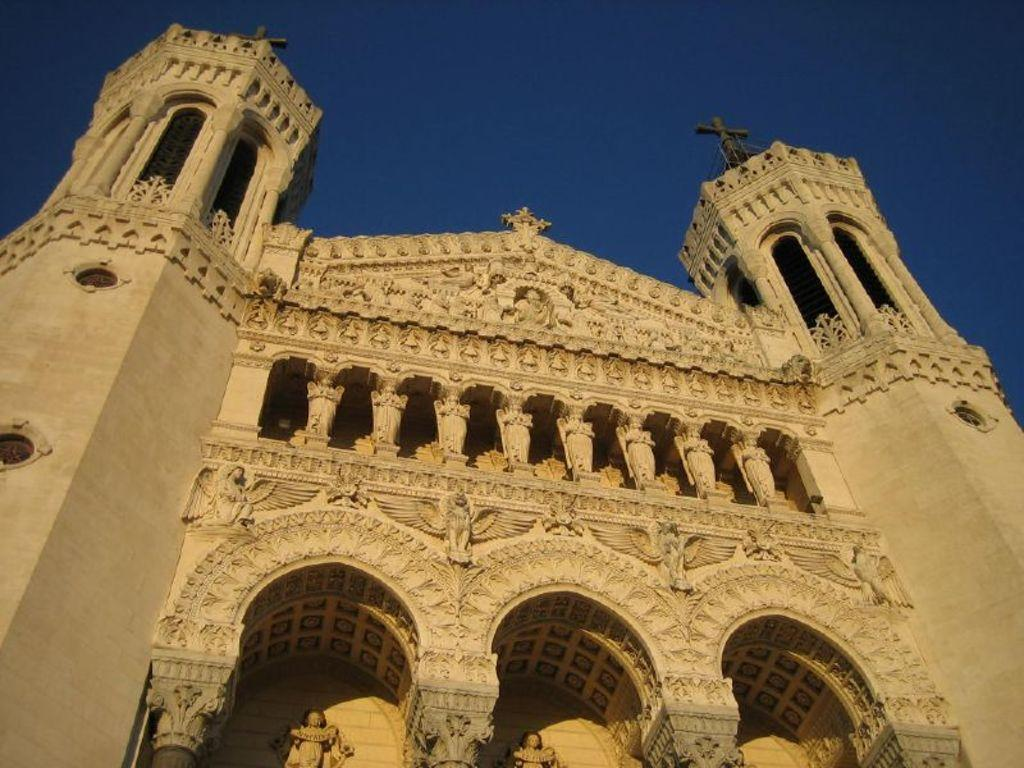What type of structure can be seen in the image? There is a building in the image. What architectural feature is present in the image? There is an arch in the image. What symbol can be seen on the building? There is a cross symbol on the building. What is visible in the background of the image? The sky is visible in the image. What verse is written on the mailbox in the image? There is no mailbox present in the image, so no verse can be observed. 